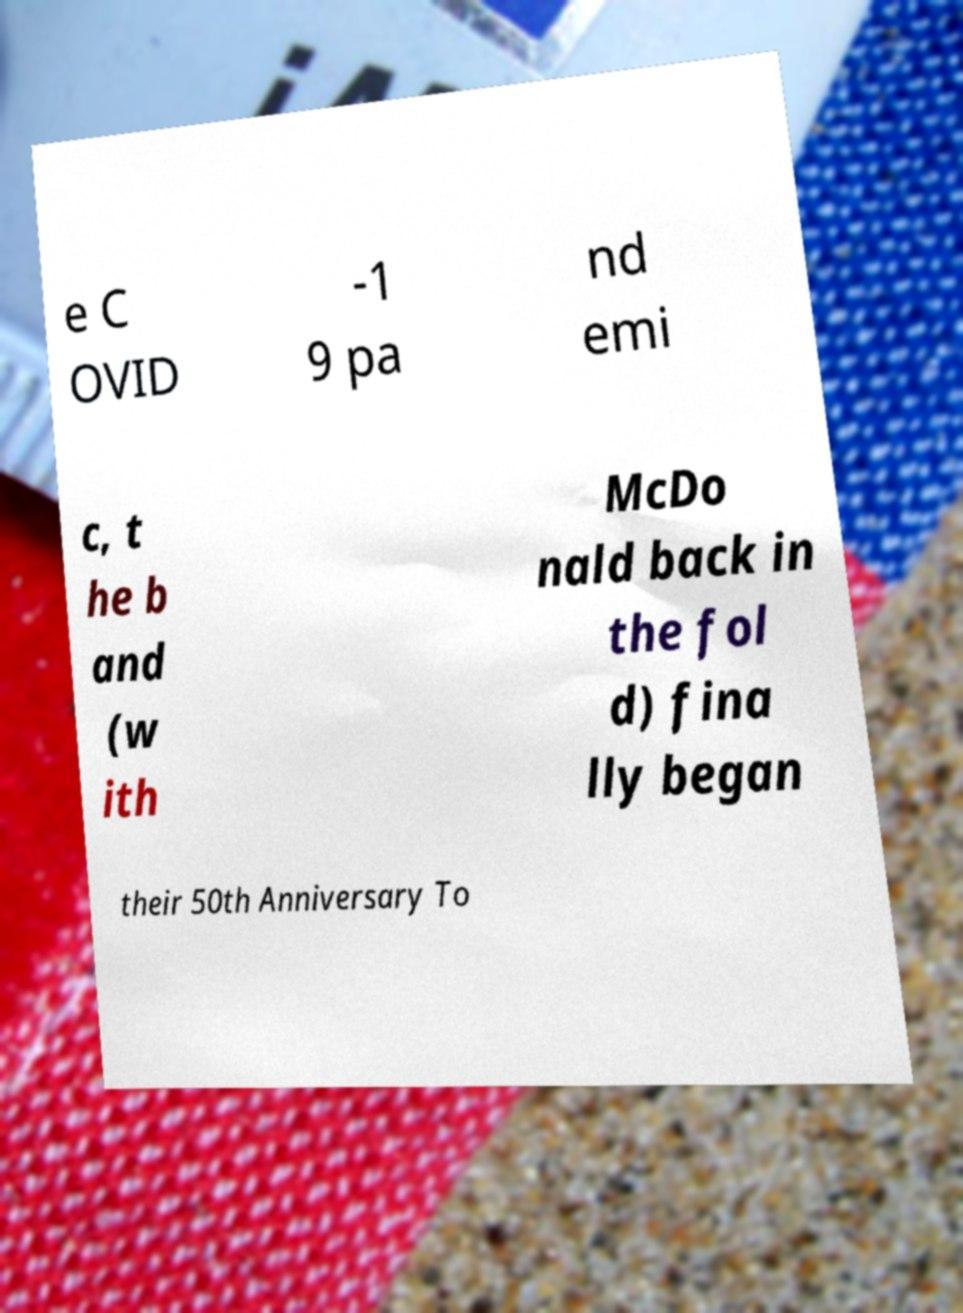Can you accurately transcribe the text from the provided image for me? e C OVID -1 9 pa nd emi c, t he b and (w ith McDo nald back in the fol d) fina lly began their 50th Anniversary To 